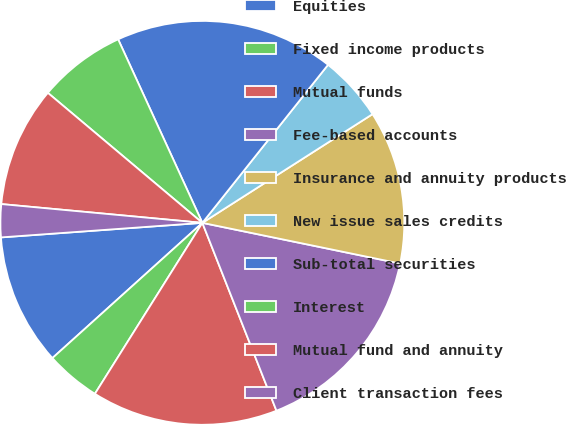Convert chart to OTSL. <chart><loc_0><loc_0><loc_500><loc_500><pie_chart><fcel>Equities<fcel>Fixed income products<fcel>Mutual funds<fcel>Fee-based accounts<fcel>Insurance and annuity products<fcel>New issue sales credits<fcel>Sub-total securities<fcel>Interest<fcel>Mutual fund and annuity<fcel>Client transaction fees<nl><fcel>10.53%<fcel>4.39%<fcel>14.91%<fcel>15.79%<fcel>12.28%<fcel>5.26%<fcel>17.54%<fcel>7.02%<fcel>9.65%<fcel>2.63%<nl></chart> 